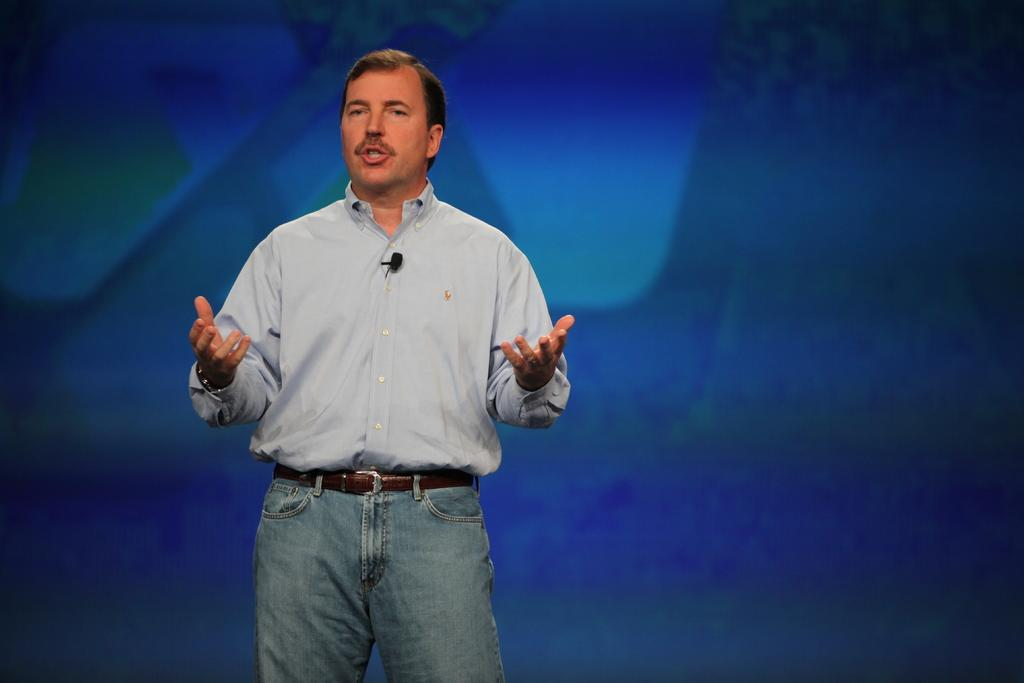What is the main subject of the image? There is a man in the image. What is the man wearing? The man is wearing a grey shirt and blue jeans. What is the man's posture in the image? The man appears to be standing. What might the man be doing in the image? The man may be trying to talk. What color is the background of the image? The background of the image is blue in color. Can you see any beans on the man's plate in the image? There is no plate or beans visible in the image. Is the man's parent present in the image? There is no indication of the man's parent in the image. 